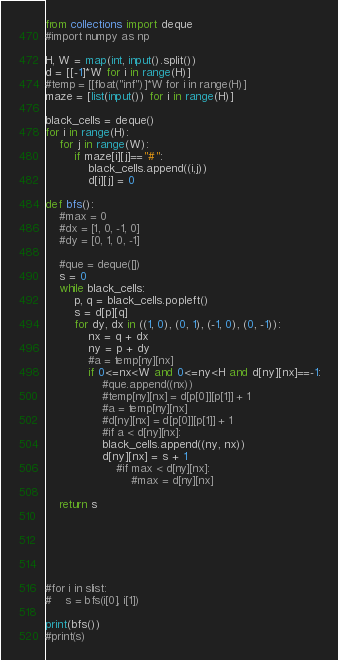<code> <loc_0><loc_0><loc_500><loc_500><_Python_>from collections import deque
#import numpy as np

H, W = map(int, input().split())
d = [[-1]*W for i in range(H)]
#temp = [[float("inf")]*W for i in range(H)]
maze = [list(input()) for i in range(H)]

black_cells = deque()
for i in range(H):
    for j in range(W):
        if maze[i][j]=="#":
            black_cells.append((i,j))
            d[i][j] = 0

def bfs():
    #max = 0
    #dx = [1, 0, -1, 0]
    #dy = [0, 1, 0, -1]

    #que = deque([])
    s = 0
    while black_cells:
        p, q = black_cells.popleft()
        s = d[p][q]
        for dy, dx in ((1, 0), (0, 1), (-1, 0), (0, -1)):
            nx = q + dx
            ny = p + dy
            #a = temp[ny][nx]
            if 0<=nx<W and 0<=ny<H and d[ny][nx]==-1:
                #que.append((nx))
                #temp[ny][nx] = d[p[0]][p[1]] + 1
                #a = temp[ny][nx]
                #d[ny][nx] = d[p[0]][p[1]] + 1
                #if a < d[ny][nx]:
                black_cells.append((ny, nx))
                d[ny][nx] = s + 1
                    #if max < d[ny][nx]:
                        #max = d[ny][nx]

    return s






#for i in slist:
#    s = bfs(i[0], i[1])

print(bfs())
#print(s)
</code> 